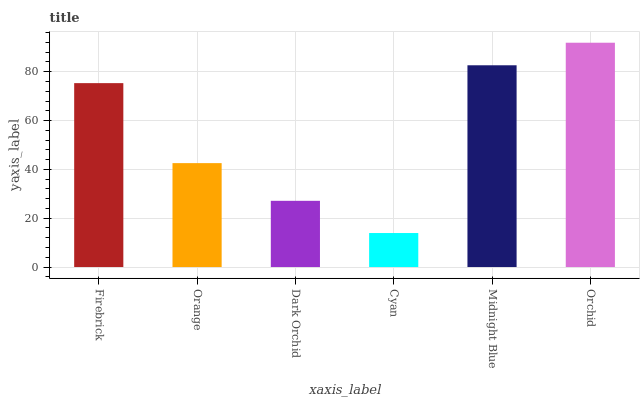Is Cyan the minimum?
Answer yes or no. Yes. Is Orchid the maximum?
Answer yes or no. Yes. Is Orange the minimum?
Answer yes or no. No. Is Orange the maximum?
Answer yes or no. No. Is Firebrick greater than Orange?
Answer yes or no. Yes. Is Orange less than Firebrick?
Answer yes or no. Yes. Is Orange greater than Firebrick?
Answer yes or no. No. Is Firebrick less than Orange?
Answer yes or no. No. Is Firebrick the high median?
Answer yes or no. Yes. Is Orange the low median?
Answer yes or no. Yes. Is Midnight Blue the high median?
Answer yes or no. No. Is Dark Orchid the low median?
Answer yes or no. No. 